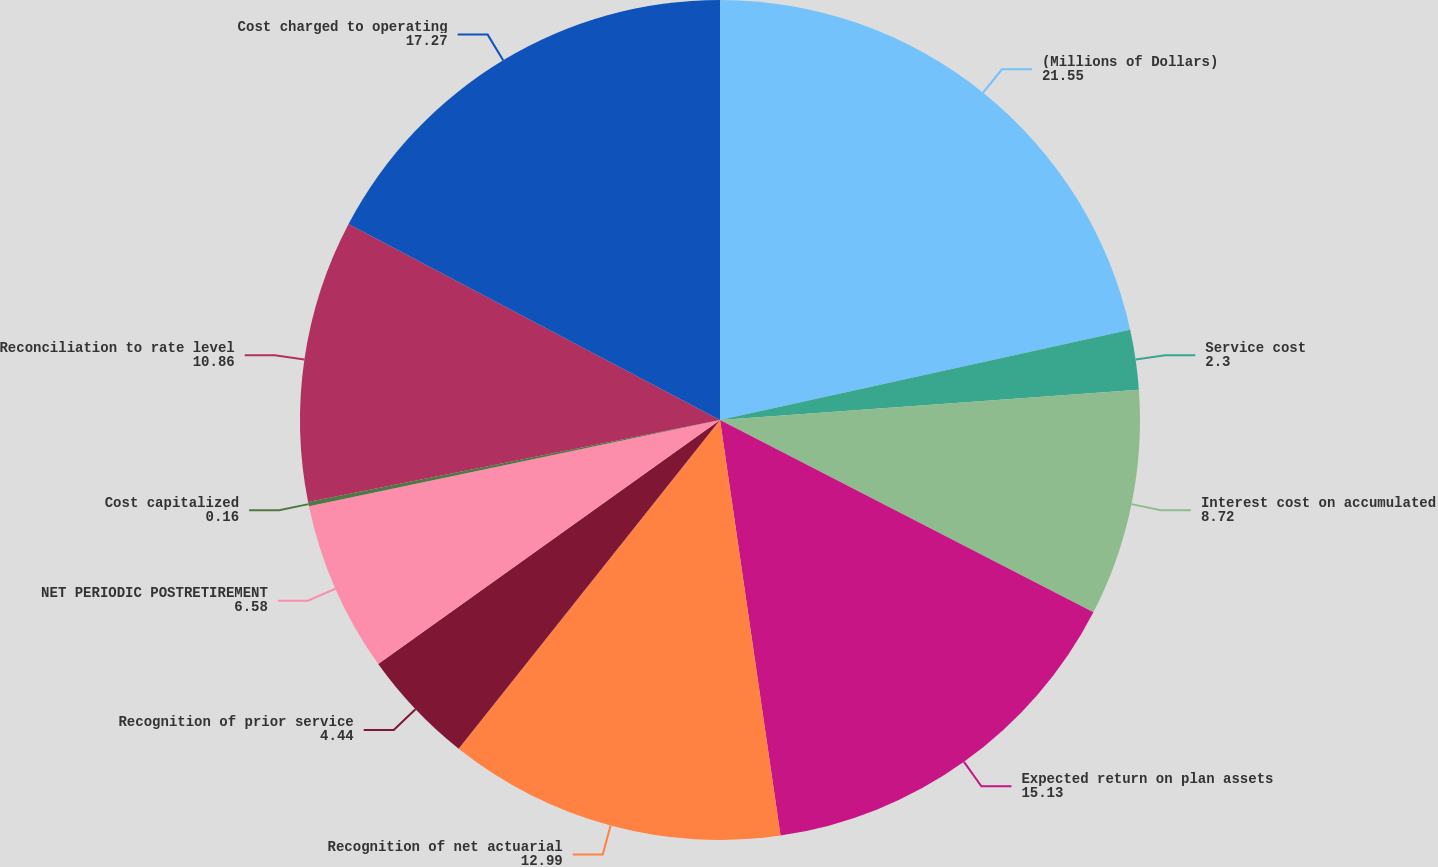Convert chart to OTSL. <chart><loc_0><loc_0><loc_500><loc_500><pie_chart><fcel>(Millions of Dollars)<fcel>Service cost<fcel>Interest cost on accumulated<fcel>Expected return on plan assets<fcel>Recognition of net actuarial<fcel>Recognition of prior service<fcel>NET PERIODIC POSTRETIREMENT<fcel>Cost capitalized<fcel>Reconciliation to rate level<fcel>Cost charged to operating<nl><fcel>21.55%<fcel>2.3%<fcel>8.72%<fcel>15.13%<fcel>12.99%<fcel>4.44%<fcel>6.58%<fcel>0.16%<fcel>10.86%<fcel>17.27%<nl></chart> 